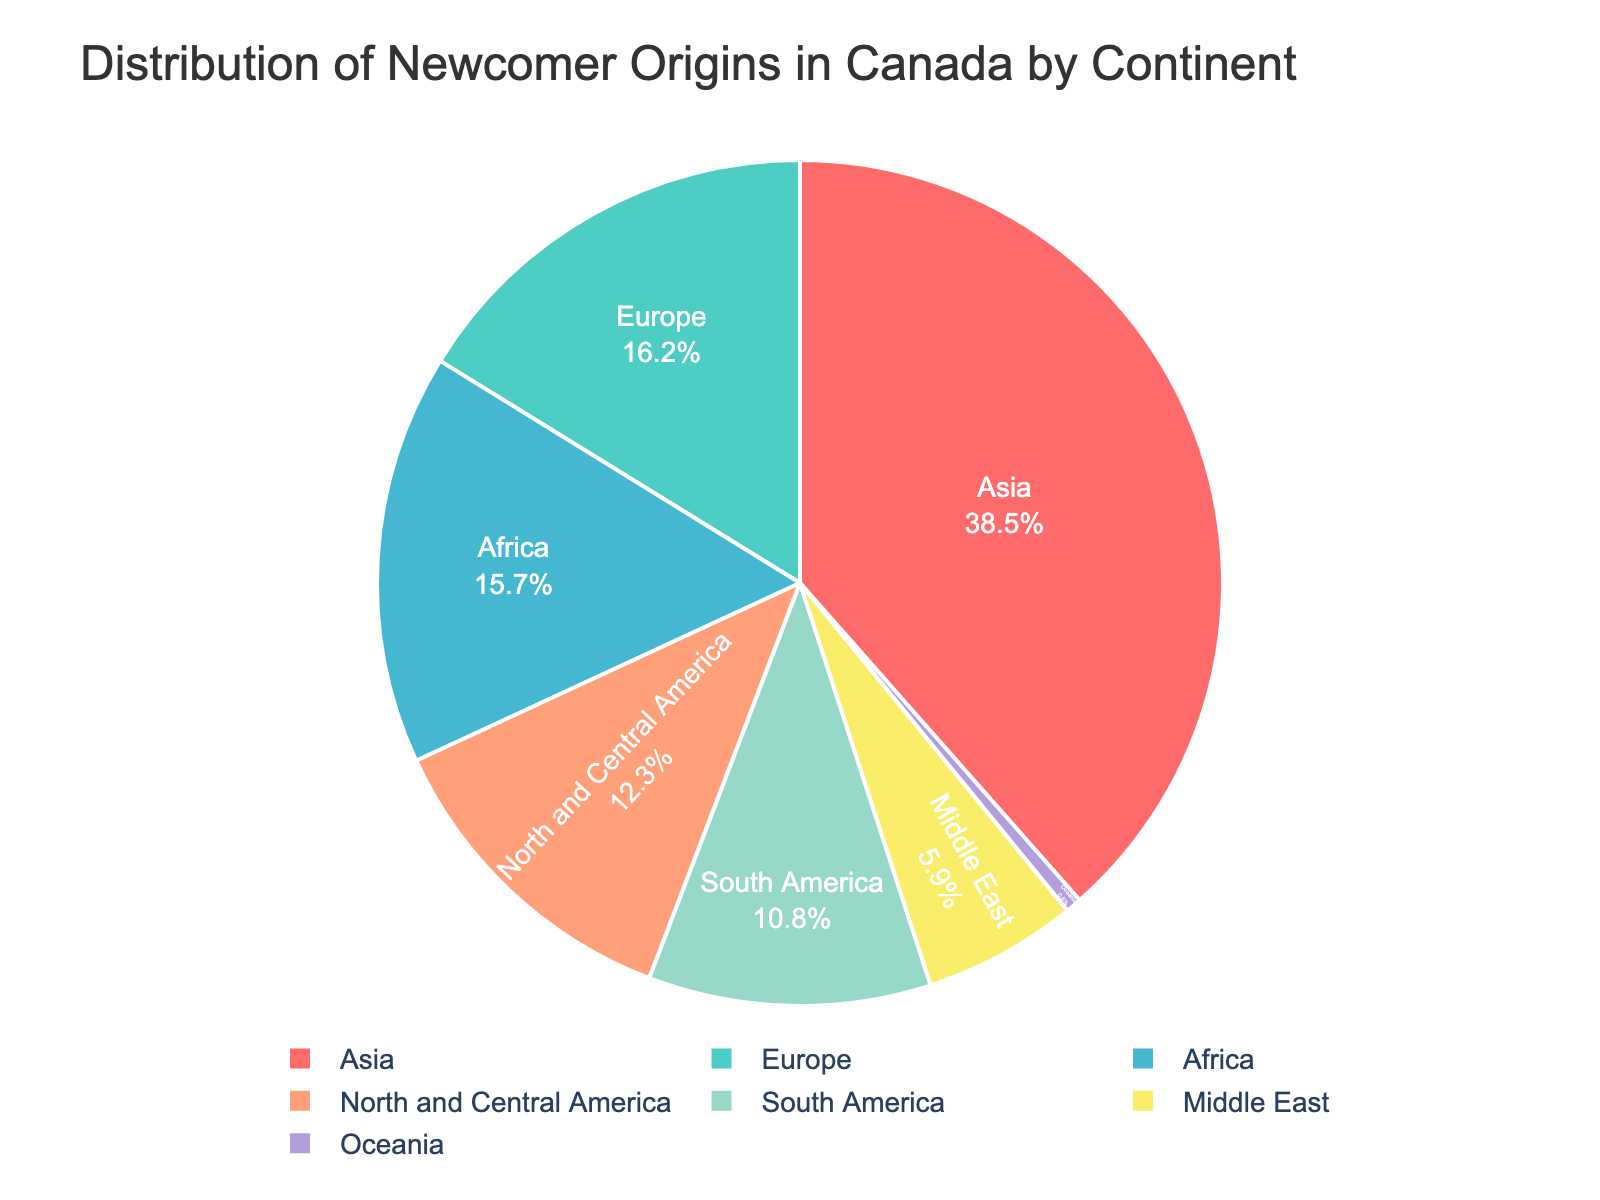What continent has the highest percentage of newcomers to Canada? The pie chart shows different continents with their respective percentages. Asia has the largest portion of the pie.
Answer: Asia Which continents together constitute more than 50% of the newcomers? Adding the percentages of Asia (38.5%) and Europe (16.2%), their combined total becomes 54.7%, which is just over 50%.
Answer: Asia and Europe What is the combined percentage of newcomers from Africa and North and Central America? The pie chart shows that Africa has 15.7% and North and Central America has 12.3%. Adding them together gives 15.7% + 12.3% = 28%.
Answer: 28% How does the percentage of newcomers from South America compare to that from the Middle East? Comparing the percentages directly: South America has 10.8% and the Middle East has 5.9%, so South America has a higher percentage.
Answer: South America has a higher percentage Which continent has the smallest percentage of newcomers, and what is it? The pie chart shows that Oceania has the smallest portion, which is 0.6%.
Answer: Oceania, 0.6% What is the difference in percentage between newcomers from Europe and Africa? Europe has 16.2% and Africa has 15.7%. The difference is 16.2% - 15.7% = 0.5%.
Answer: 0.5% What percentage of newcomers come from continents outside of Asia? First, identify that Asia has 38.5% newcomers. Then subtract this from 100%: 100% - 38.5% = 61.5%.
Answer: 61.5% If you combine newcomers from the Middle East and Oceania, is their total percentage now equal to any single continent's percentage? The combined percentage is 5.9% + 0.6% = 6.5%. This does not match any single continent's percentage as shown in the chart.
Answer: No Which continents have percentages between 10% and 20%? Check the pie chart to see the percentages for each continent: Europe (16.2%), Africa (15.7%), North and Central America (12.3%), and South America (10.8%) fall within this range.
Answer: Europe, Africa, North and Central America, South America Is the combined percentage for North and Central America and South America larger than the percentage for Europe? North and Central America has 12.3% and South America has 10.8%. Their combined percentage is 12.3% + 10.8% = 23.1%, which is larger than Europe's 16.2%.
Answer: Yes 